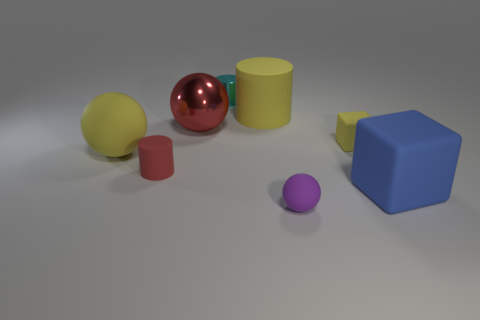Can you tell me about the shapes and colors of the objects in this scene? Certainly! The image features geometric shapes that include a red sphere, a yellow cylinder, a green truncated cone, a blue cube, a small purple sphere, and a pink cylinder. Each object's color is bright and distinct, providing a clear contrast against the neutral background. 